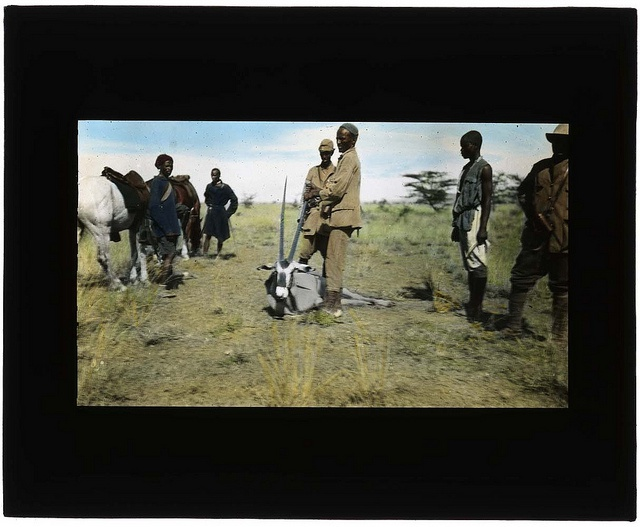Describe the objects in this image and their specific colors. I can see people in white, black, darkgreen, and gray tones, horse in white, black, lightgray, darkgray, and gray tones, people in white, black, gray, darkgray, and darkgreen tones, people in white, tan, gray, and black tones, and horse in white, darkgray, gray, black, and lightgray tones in this image. 